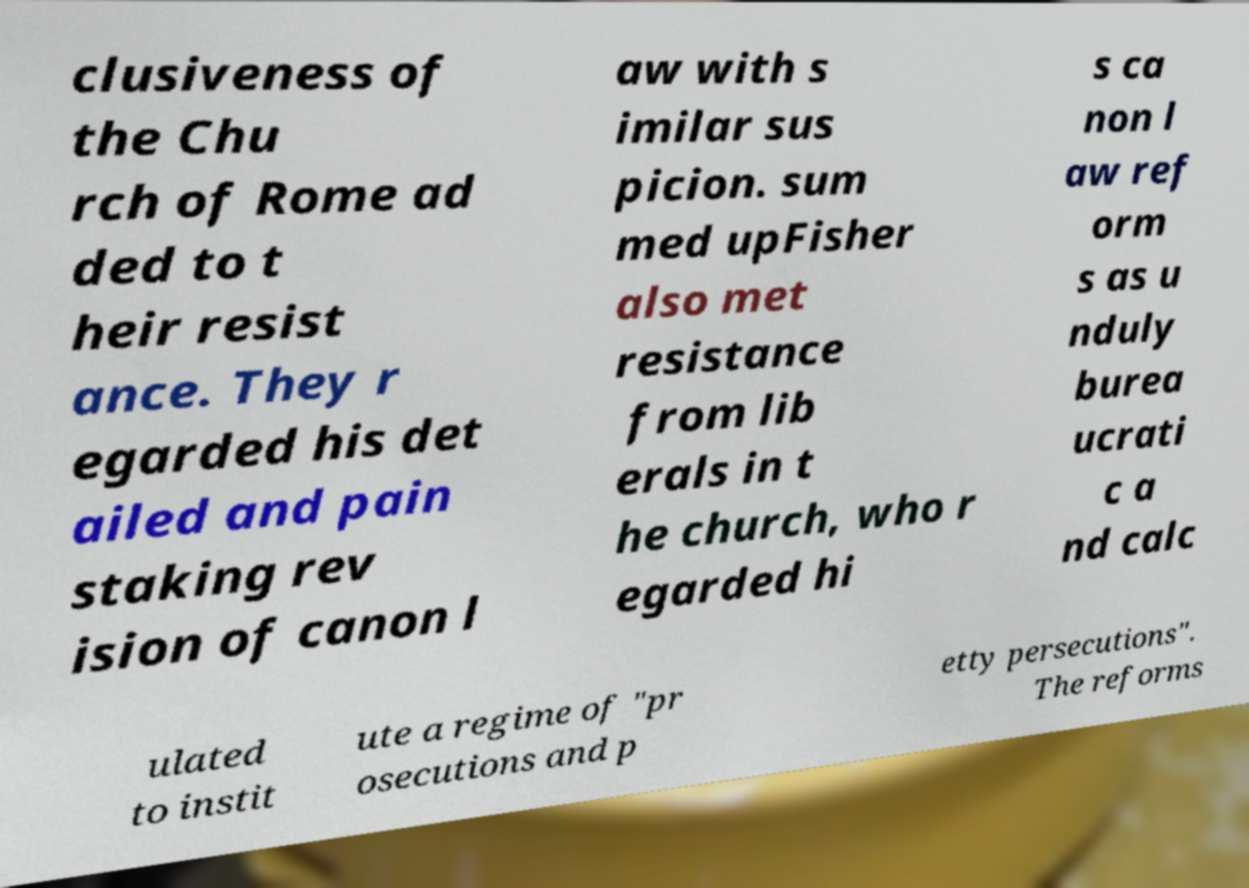There's text embedded in this image that I need extracted. Can you transcribe it verbatim? clusiveness of the Chu rch of Rome ad ded to t heir resist ance. They r egarded his det ailed and pain staking rev ision of canon l aw with s imilar sus picion. sum med upFisher also met resistance from lib erals in t he church, who r egarded hi s ca non l aw ref orm s as u nduly burea ucrati c a nd calc ulated to instit ute a regime of "pr osecutions and p etty persecutions". The reforms 